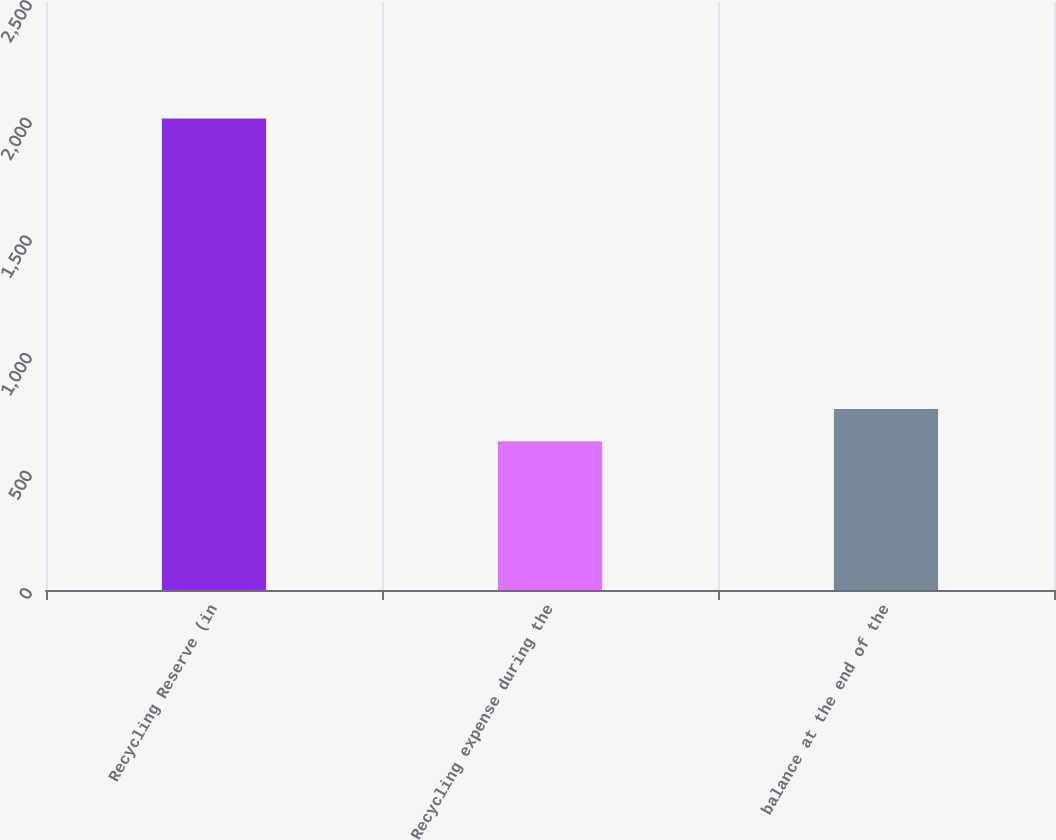<chart> <loc_0><loc_0><loc_500><loc_500><bar_chart><fcel>Recycling Reserve (in<fcel>Recycling expense during the<fcel>balance at the end of the<nl><fcel>2005<fcel>632<fcel>769.3<nl></chart> 